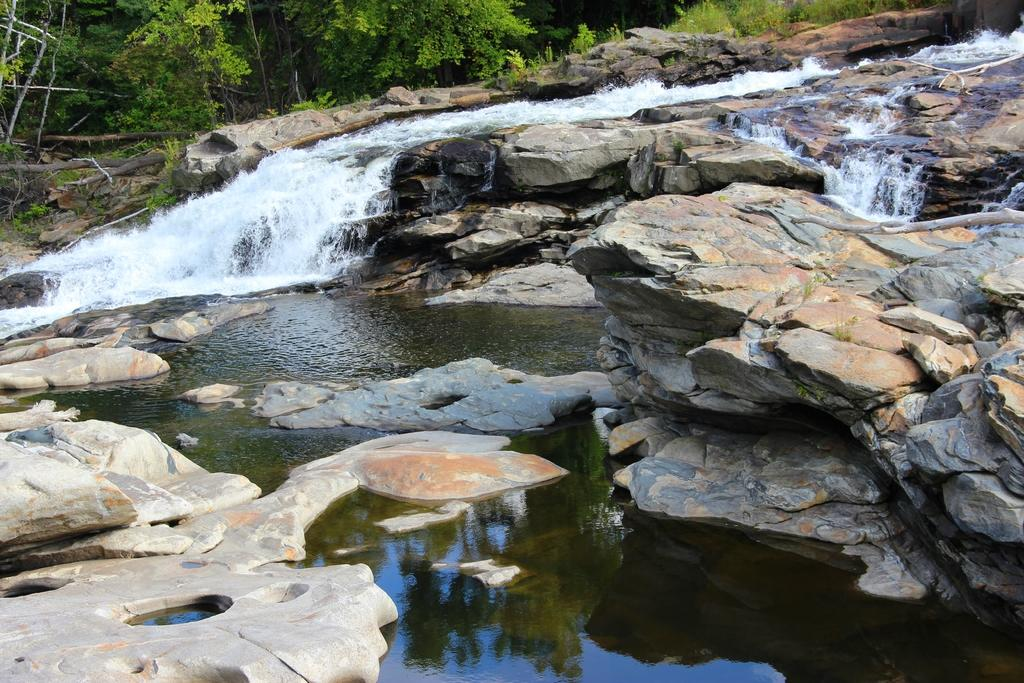What natural feature is the main subject of the image? There is a waterfall in the image. What can be seen in the background of the image? There are trees visible in the background of the image. What is at the bottom of the waterfall? There is water at the bottom of the waterfall. What is reflected on the water's surface? The reflection of the sky is visible on the water. Where is the crate of beans located in the image? There is no crate of beans present in the image. 